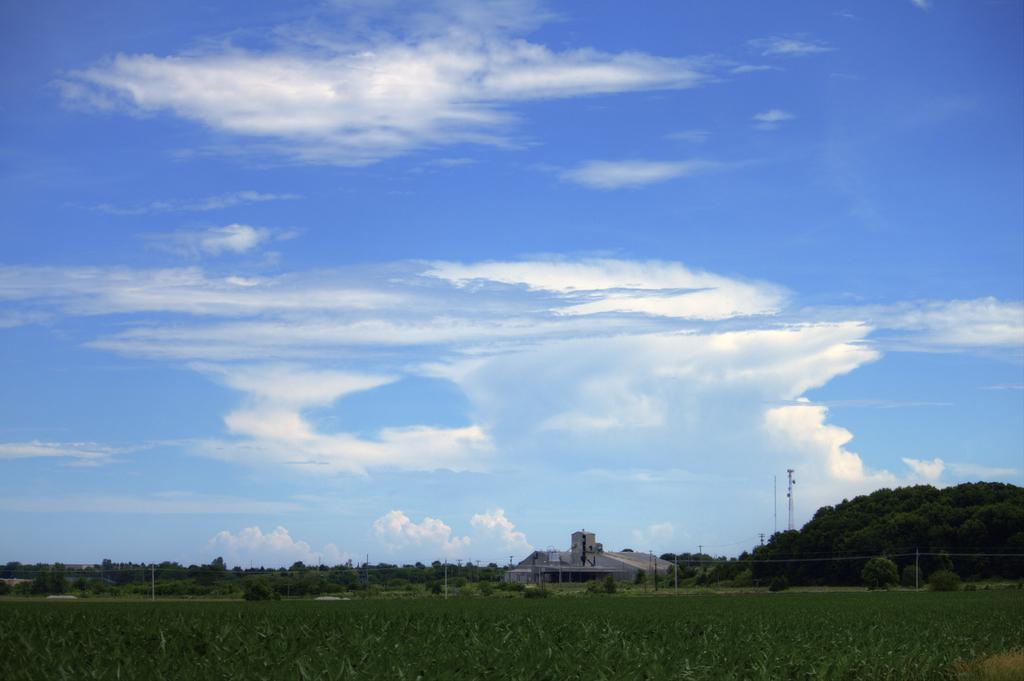What type of living organisms can be seen in the image? Plants can be seen in the image. What structures are present in the image? Poles and a building are present in the image. What can be seen in the background of the image? Trees, towers, and clouds can be seen in the background of the image. What type of pot is visible in the image? There is no pot present in the image. What is the aftermath of the storm in the image? There is no storm or aftermath mentioned in the image; it features plants, poles, a building, trees, towers, and clouds. 